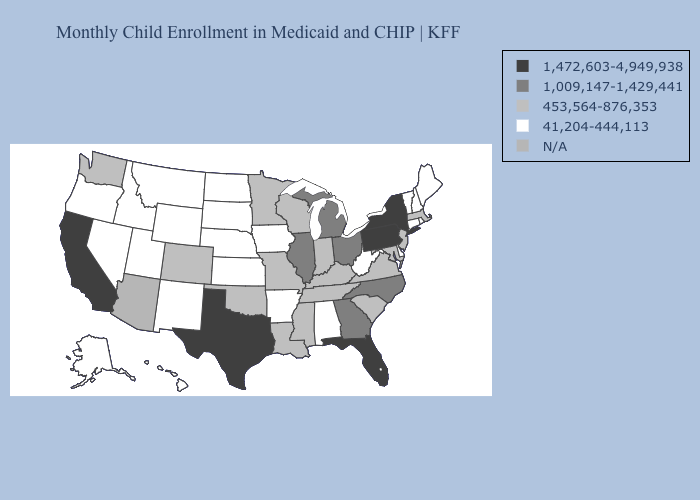Among the states that border Virginia , which have the lowest value?
Quick response, please. West Virginia. Name the states that have a value in the range 453,564-876,353?
Short answer required. Colorado, Indiana, Kentucky, Louisiana, Maryland, Massachusetts, Minnesota, Mississippi, Missouri, New Jersey, Oklahoma, South Carolina, Tennessee, Virginia, Washington, Wisconsin. Does Minnesota have the highest value in the MidWest?
Be succinct. No. Does Oklahoma have the lowest value in the USA?
Concise answer only. No. What is the value of Rhode Island?
Answer briefly. 41,204-444,113. What is the highest value in the USA?
Be succinct. 1,472,603-4,949,938. Does the first symbol in the legend represent the smallest category?
Be succinct. No. Does Connecticut have the lowest value in the Northeast?
Be succinct. Yes. Name the states that have a value in the range 1,009,147-1,429,441?
Concise answer only. Georgia, Illinois, Michigan, North Carolina, Ohio. What is the value of Vermont?
Answer briefly. 41,204-444,113. Which states hav the highest value in the West?
Answer briefly. California. Which states have the lowest value in the USA?
Write a very short answer. Alabama, Alaska, Arkansas, Connecticut, Delaware, Hawaii, Idaho, Iowa, Kansas, Maine, Montana, Nebraska, Nevada, New Hampshire, New Mexico, North Dakota, Oregon, Rhode Island, South Dakota, Utah, Vermont, West Virginia, Wyoming. Name the states that have a value in the range 1,009,147-1,429,441?
Short answer required. Georgia, Illinois, Michigan, North Carolina, Ohio. What is the value of North Dakota?
Answer briefly. 41,204-444,113. 